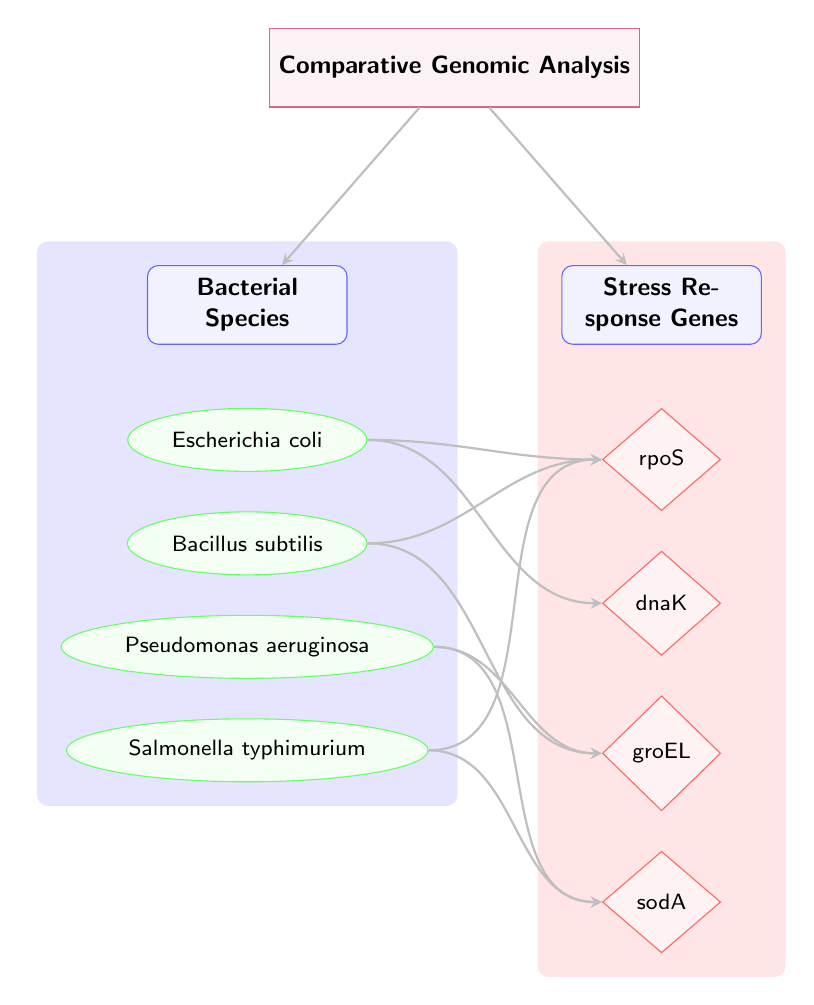What is the title of the analysis process? The title node at the top of the diagram directly states "Comparative Genomic Analysis."
Answer: Comparative Genomic Analysis How many bacterial species are represented in the diagram? The species nodes listed are Escherichia coli, Bacillus subtilis, Pseudomonas aeruginosa, and Salmonella typhimurium, which total four species.
Answer: 4 Which gene is connected to both Escherichia coli and Salmonella typhimurium? The rpoS gene has edges leading to both the Escherichia coli and Salmonella typhimurium species nodes.
Answer: rpoS Which stress response gene is unique to Bacillus subtilis? The groEL gene is connected only to the Bacillus subtilis species node in the diagram.
Answer: groEL How many connections are there from Pseudomonas aeruginosa? The Pseudomonas aeruginosa node has connections leading to two genes: groEL and sodA, resulting in two total connections.
Answer: 2 Which two species share the same stress response gene? Both Escherichia coli and Bacillus subtilis share a connection to the rpoS gene.
Answer: rpoS What color is used to represent the species nodes? The species nodes are represented using a green color scheme, as indicated in the diagram legend.
Answer: Green Which process is depicted as the origin of the connections in the diagram? The process node titled "Comparative Genomic Analysis" is the central starting point for the connections in the diagram.
Answer: Comparative Genomic Analysis 